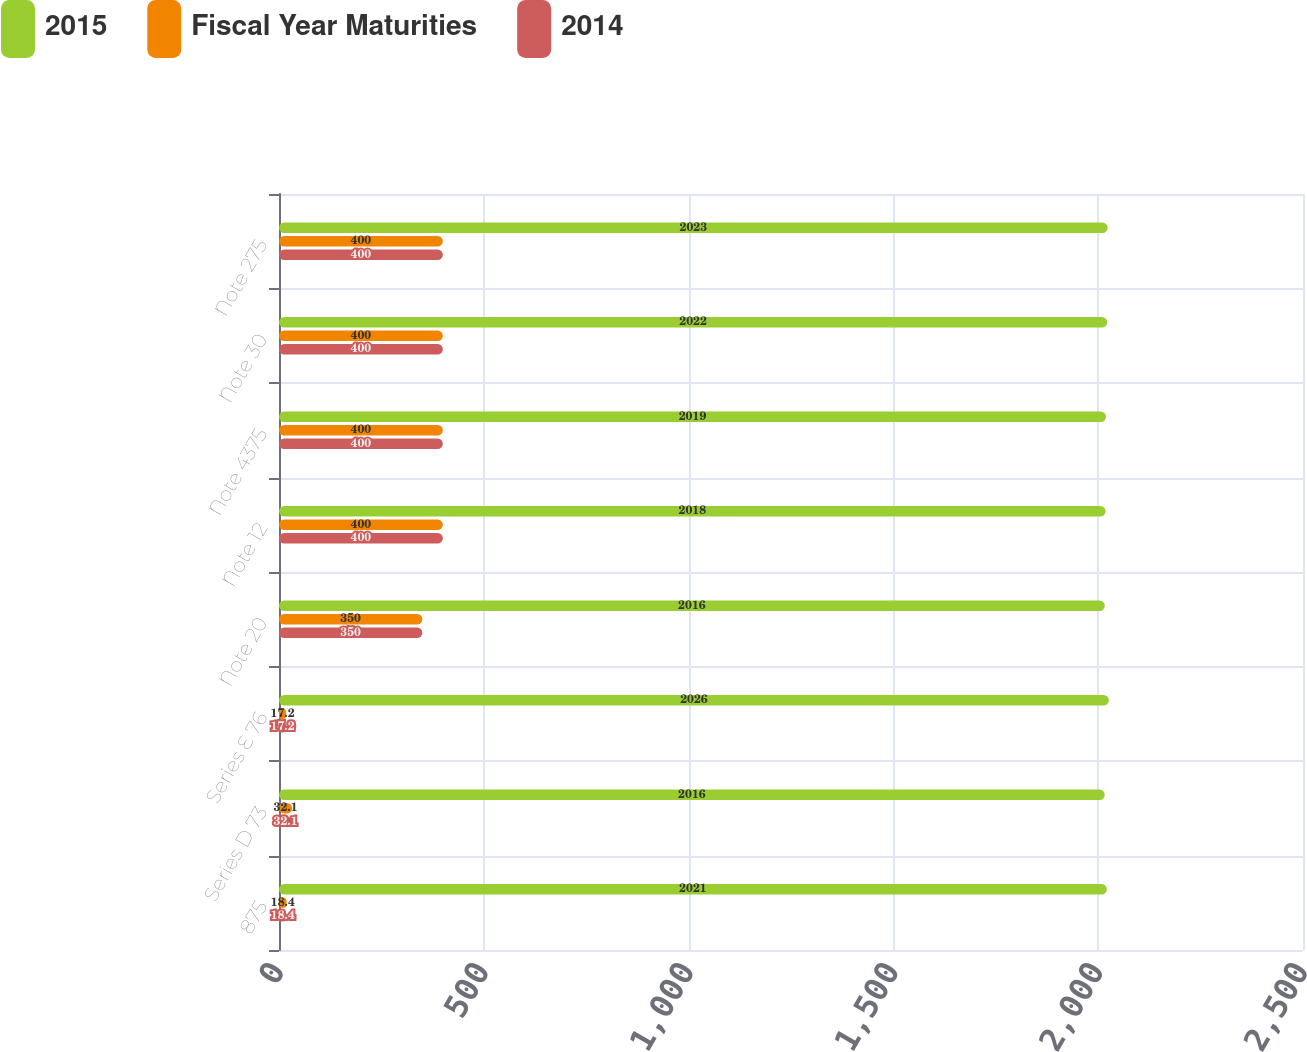<chart> <loc_0><loc_0><loc_500><loc_500><stacked_bar_chart><ecel><fcel>875<fcel>Series D 73<fcel>Series E 76<fcel>Note 20<fcel>Note 12<fcel>Note 4375<fcel>Note 30<fcel>Note 275<nl><fcel>2015<fcel>2021<fcel>2016<fcel>2026<fcel>2016<fcel>2018<fcel>2019<fcel>2022<fcel>2023<nl><fcel>Fiscal Year Maturities<fcel>18.4<fcel>32.1<fcel>17.2<fcel>350<fcel>400<fcel>400<fcel>400<fcel>400<nl><fcel>2014<fcel>18.4<fcel>32.1<fcel>17.2<fcel>350<fcel>400<fcel>400<fcel>400<fcel>400<nl></chart> 